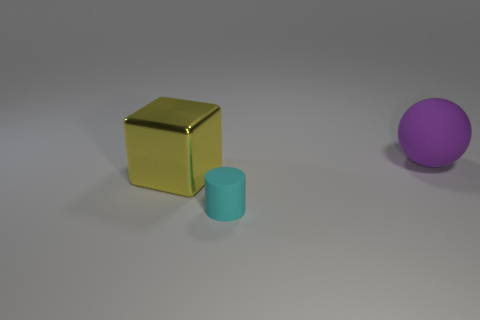Add 3 tiny cyan things. How many objects exist? 6 Subtract all balls. How many objects are left? 2 Subtract 1 purple spheres. How many objects are left? 2 Subtract all cyan rubber cylinders. Subtract all big purple objects. How many objects are left? 1 Add 3 cyan matte cylinders. How many cyan matte cylinders are left? 4 Add 3 tiny cyan rubber cylinders. How many tiny cyan rubber cylinders exist? 4 